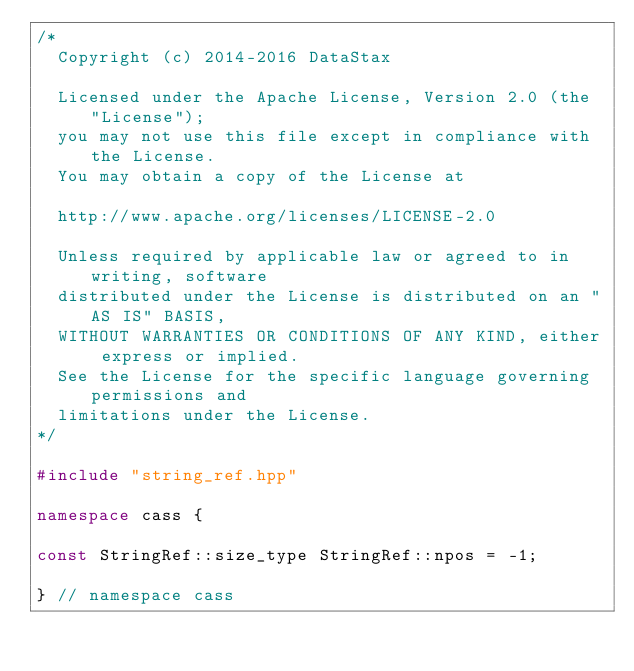Convert code to text. <code><loc_0><loc_0><loc_500><loc_500><_C++_>/*
  Copyright (c) 2014-2016 DataStax

  Licensed under the Apache License, Version 2.0 (the "License");
  you may not use this file except in compliance with the License.
  You may obtain a copy of the License at

  http://www.apache.org/licenses/LICENSE-2.0

  Unless required by applicable law or agreed to in writing, software
  distributed under the License is distributed on an "AS IS" BASIS,
  WITHOUT WARRANTIES OR CONDITIONS OF ANY KIND, either express or implied.
  See the License for the specific language governing permissions and
  limitations under the License.
*/

#include "string_ref.hpp"

namespace cass {

const StringRef::size_type StringRef::npos = -1;

} // namespace cass

</code> 